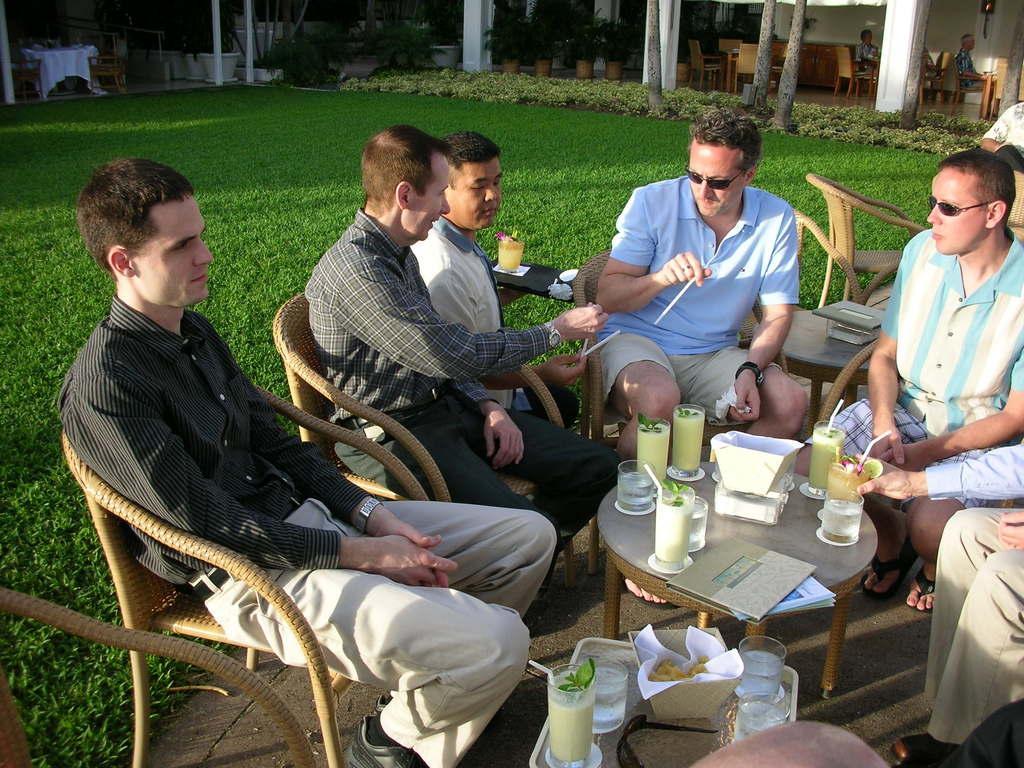Can you describe this image briefly? This is the picture of group of people sitting in chairs and in table there are glass , paper, book ,tissues and in the back ground there are plants , grass and house. 